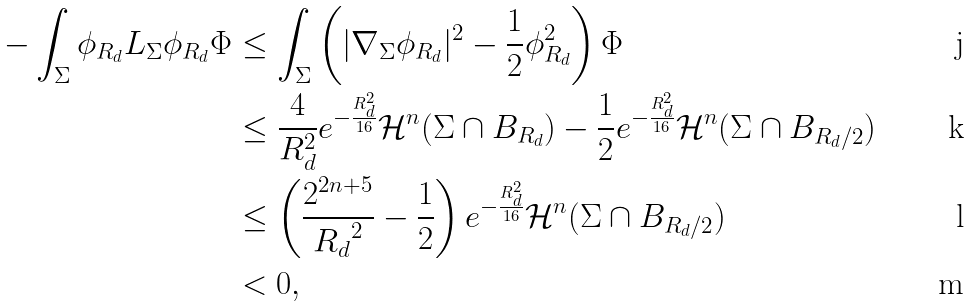Convert formula to latex. <formula><loc_0><loc_0><loc_500><loc_500>- \int _ { \Sigma } \phi _ { R _ { d } } L _ { \Sigma } \phi _ { R _ { d } } \Phi & \leq \int _ { \Sigma } \left ( | \nabla _ { \Sigma } \phi _ { R _ { d } } | ^ { 2 } - \frac { 1 } { 2 } \phi _ { R _ { d } } ^ { 2 } \right ) \Phi \\ & \leq \frac { 4 } { R _ { d } ^ { 2 } } e ^ { - \frac { R _ { d } ^ { 2 } } { 1 6 } } \mathcal { H } ^ { n } ( \Sigma \cap B _ { R _ { d } } ) - \frac { 1 } { 2 } e ^ { - \frac { R _ { d } ^ { 2 } } { 1 6 } } \mathcal { H } ^ { n } ( \Sigma \cap B _ { R _ { d } / 2 } ) \\ & \leq \left ( \frac { 2 ^ { 2 n + 5 } } { { R _ { d } } ^ { 2 } } - \frac { 1 } { 2 } \right ) e ^ { - \frac { R _ { d } ^ { 2 } } { 1 6 } } \mathcal { H } ^ { n } ( \Sigma \cap B _ { R _ { d } / 2 } ) \\ & < 0 ,</formula> 